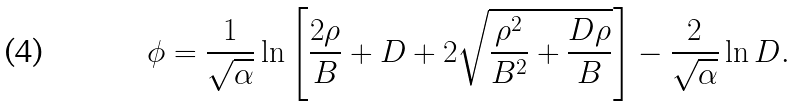<formula> <loc_0><loc_0><loc_500><loc_500>\phi = \frac { 1 } { \sqrt { \alpha } } \ln \left [ \frac { 2 \rho } { B } + D + 2 \sqrt { \frac { \rho ^ { 2 } } { B ^ { 2 } } + \frac { D \rho } { B } } \right ] - \frac { 2 } { \sqrt { \alpha } } \ln D .</formula> 